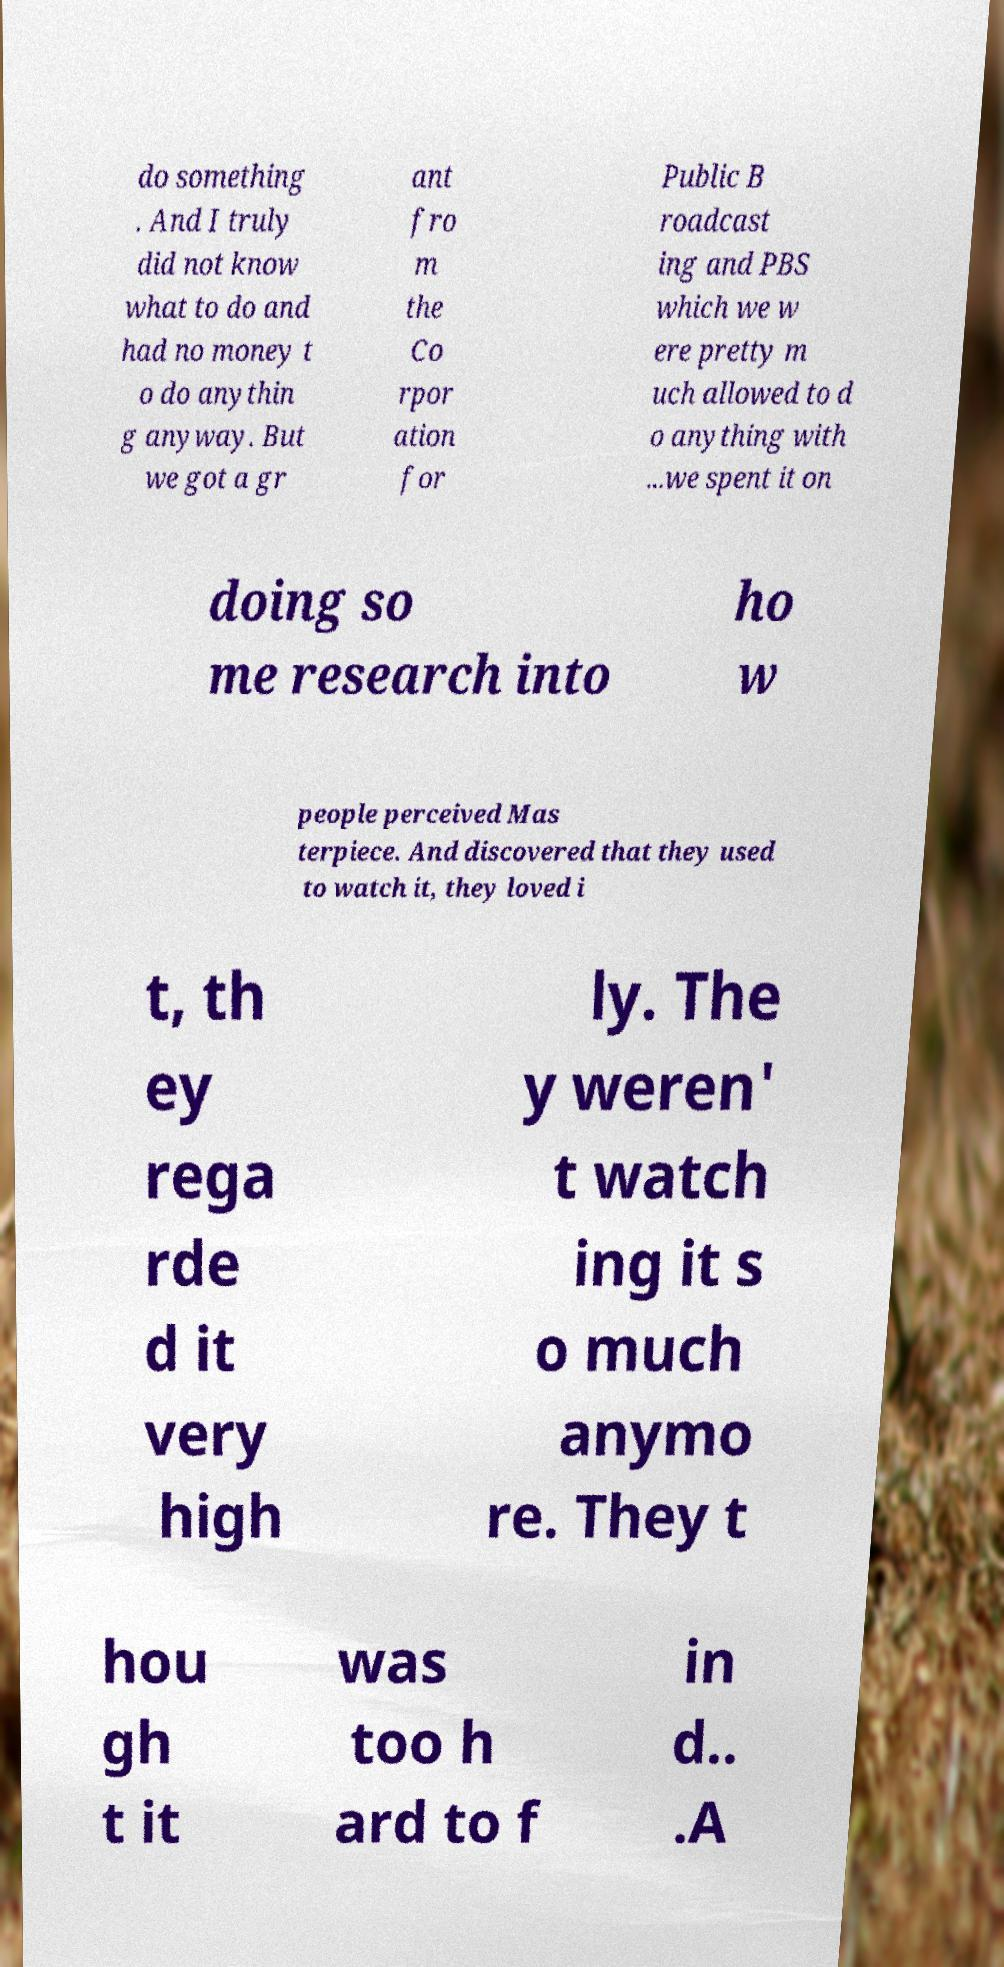For documentation purposes, I need the text within this image transcribed. Could you provide that? do something . And I truly did not know what to do and had no money t o do anythin g anyway. But we got a gr ant fro m the Co rpor ation for Public B roadcast ing and PBS which we w ere pretty m uch allowed to d o anything with ...we spent it on doing so me research into ho w people perceived Mas terpiece. And discovered that they used to watch it, they loved i t, th ey rega rde d it very high ly. The y weren' t watch ing it s o much anymo re. They t hou gh t it was too h ard to f in d.. .A 